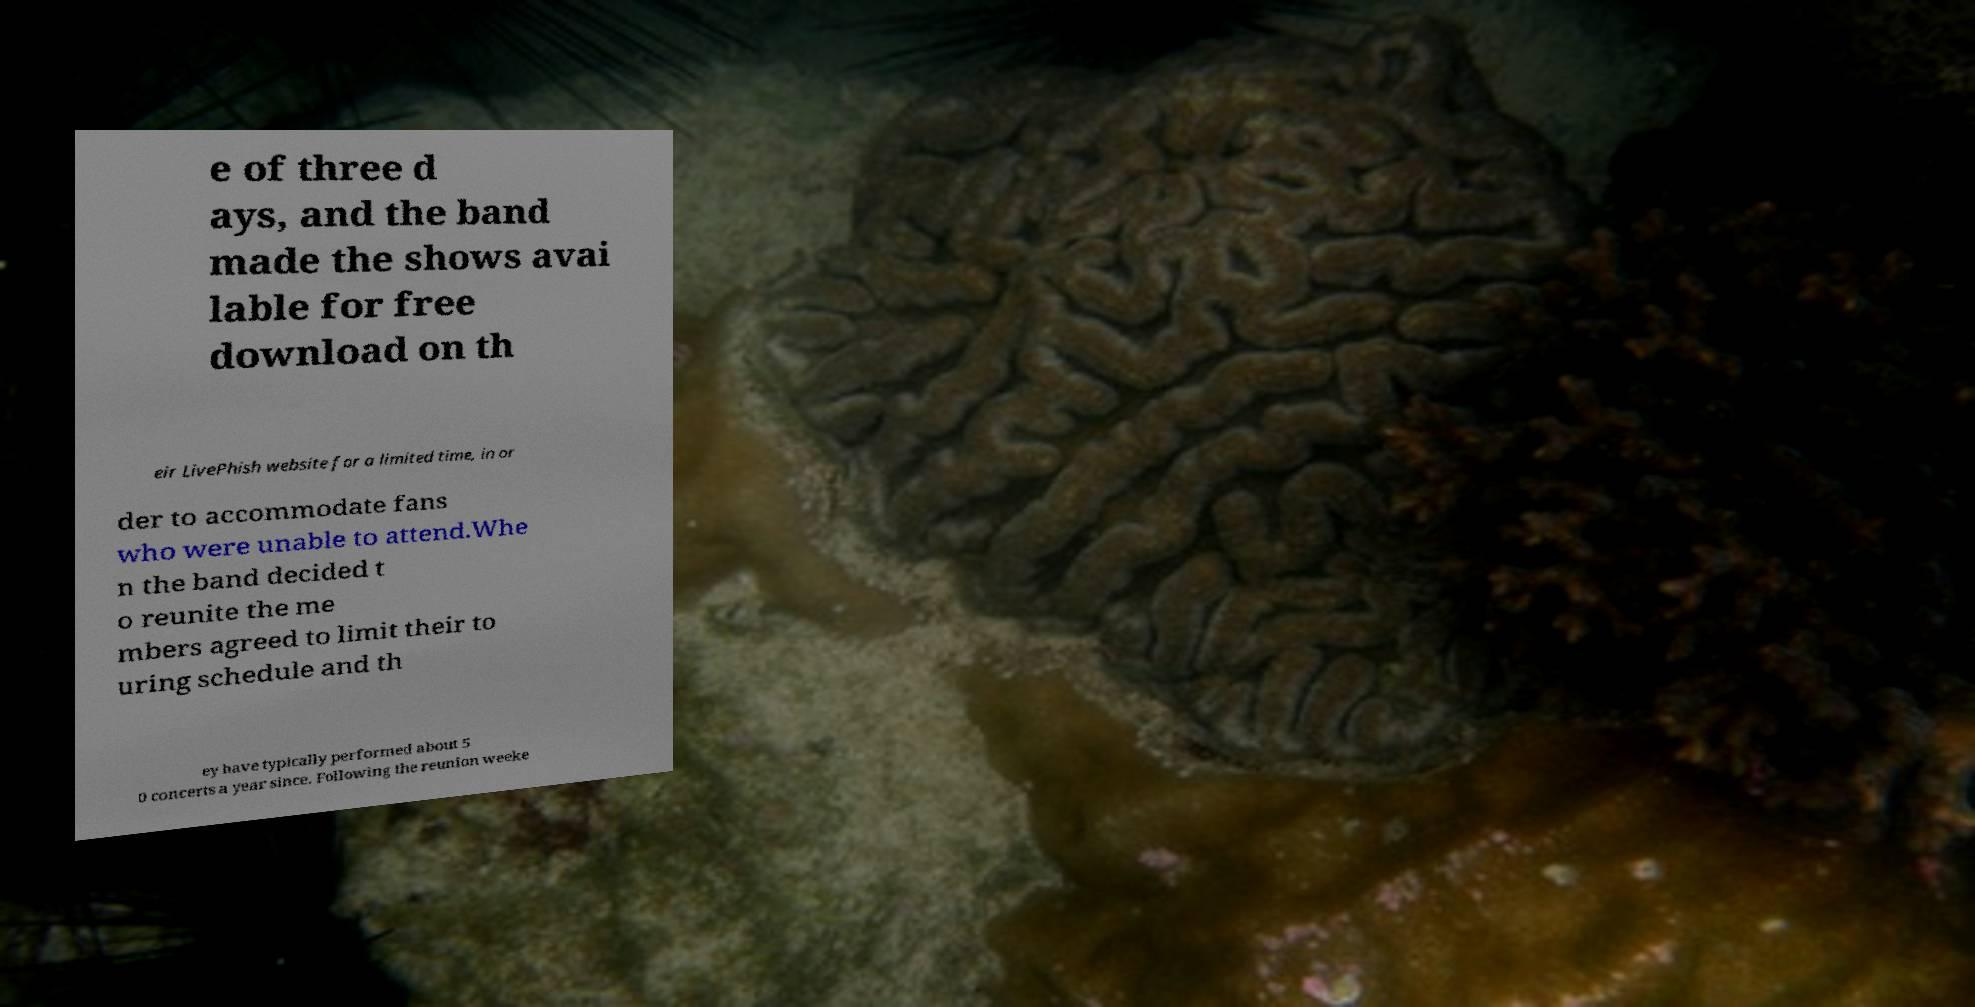Can you read and provide the text displayed in the image?This photo seems to have some interesting text. Can you extract and type it out for me? e of three d ays, and the band made the shows avai lable for free download on th eir LivePhish website for a limited time, in or der to accommodate fans who were unable to attend.Whe n the band decided t o reunite the me mbers agreed to limit their to uring schedule and th ey have typically performed about 5 0 concerts a year since. Following the reunion weeke 